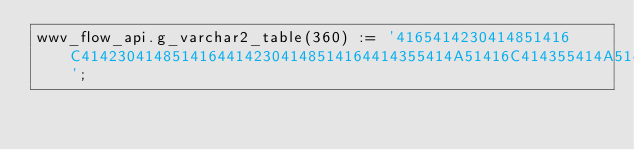<code> <loc_0><loc_0><loc_500><loc_500><_SQL_>wwv_flow_api.g_varchar2_table(360) := '4165414230414851416C41423041485141644142304148514164414355414A51416C414355414A514164414355414A5141674143554148514164414355414A51416C414355414A51416C414355414A514165414234414867416C41435541494141674143';</code> 